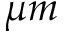Convert formula to latex. <formula><loc_0><loc_0><loc_500><loc_500>\mu m</formula> 